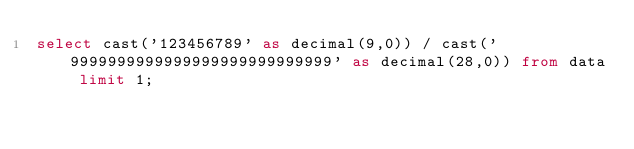Convert code to text. <code><loc_0><loc_0><loc_500><loc_500><_SQL_>select cast('123456789' as decimal(9,0)) / cast('9999999999999999999999999999' as decimal(28,0)) from data limit 1;
</code> 